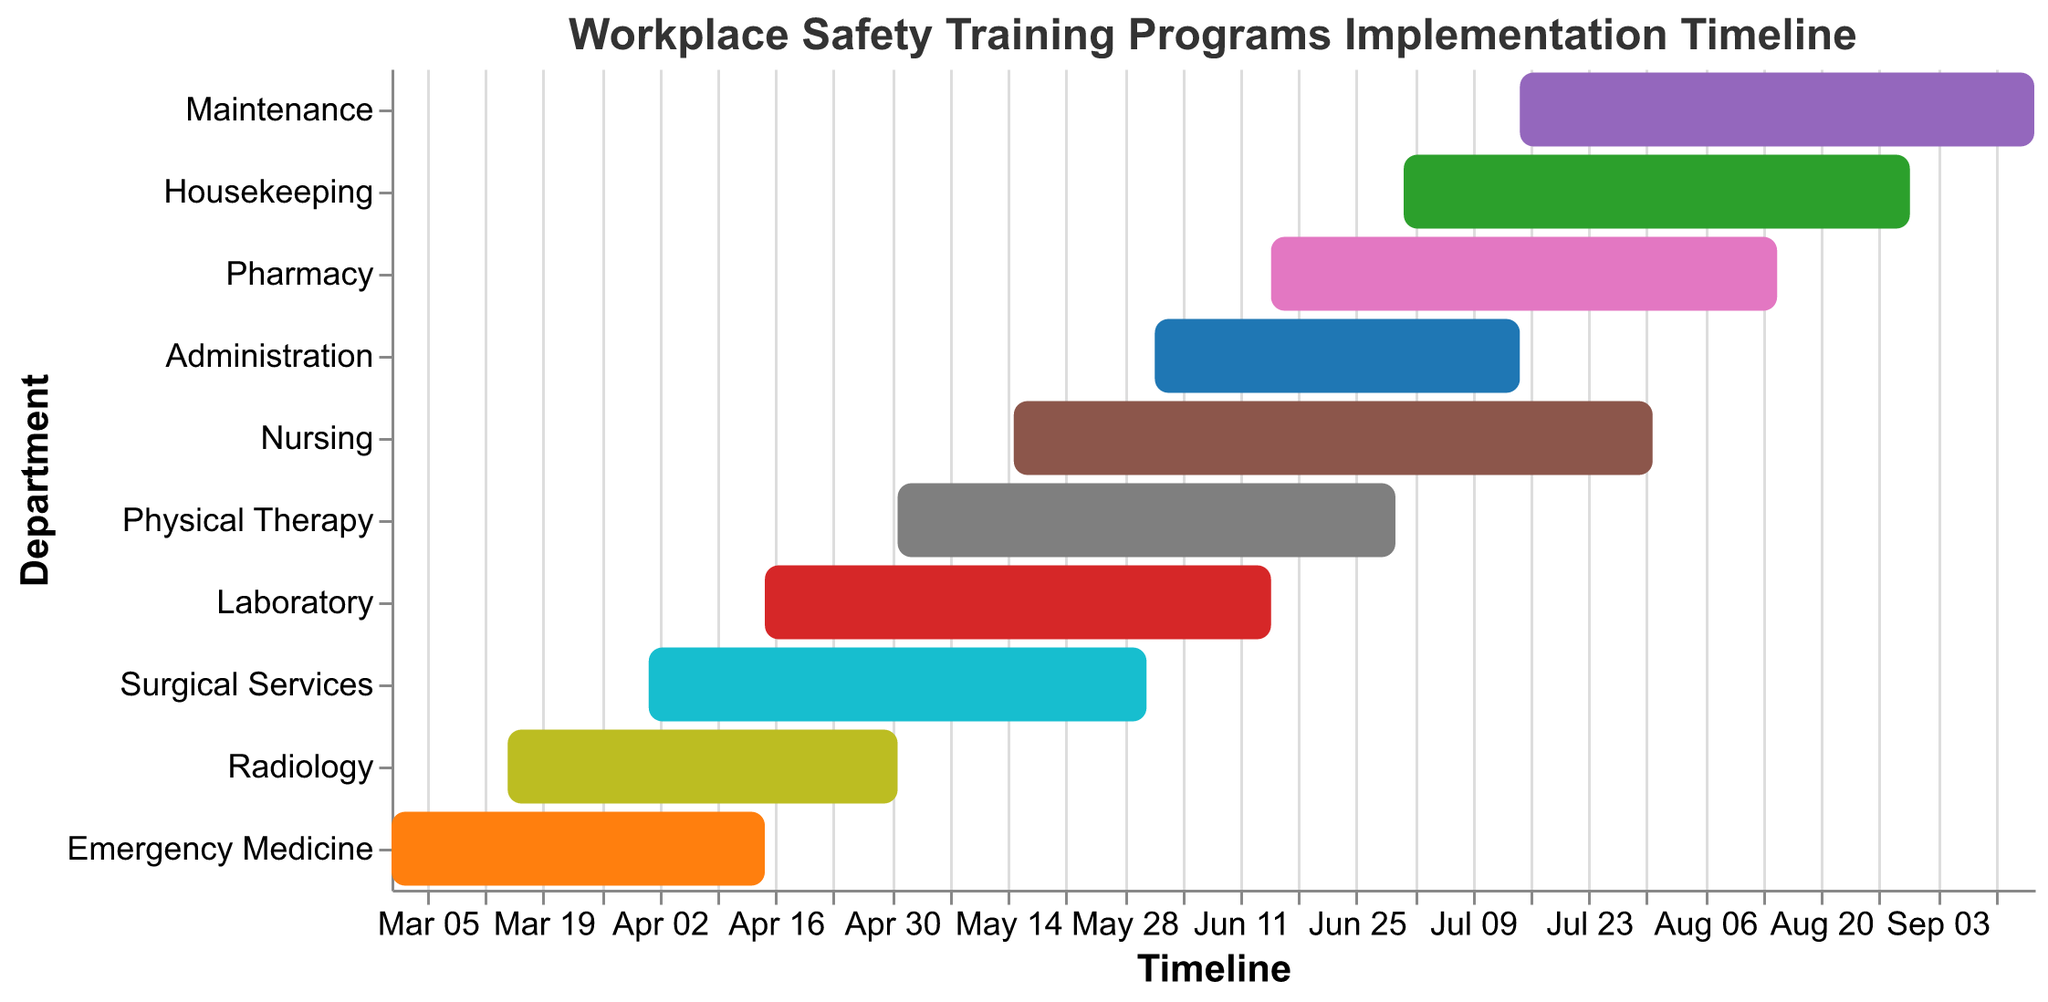How many departments have their training programs starting after June 1st, 2023? To find this, look at the start dates on the x-axis and count the departments whose bars begin after June 1st, 2023.
Answer: 5 Which department has the longest duration for its training program? Check the length of the bars by comparing the start and end dates for each department. The department with the longest bar is the one with the longest duration.
Answer: Maintenance When does the Laboratory department start and end its training program? Refer to the Laboratory department bar and look at the tooltip or x-axis for the start and end dates.
Answer: April 15, 2023 - June 15, 2023 Are there any departments that have overlapping training periods? Identify overlapping bars by checking if any start dates occur before other department’s end dates within the same timeframe.
Answer: Yes, multiple departments overlap Which two departments have the closest start dates? Compare the start dates of all departments to find the pair with the smallest difference in start dates.
Answer: Emergency Medicine and Radiology What is the total number of days for the Nursing training program? Calculate the difference between the start and end dates for Nursing. May 15, 2023 to July 31, 2023 results in (31+30+15) days.
Answer: 77 days How many departments have their training programs extending into August 2023? Identify the departments that have end dates in August 2023 by looking at the end section of the bars.
Answer: 4 Is there a department that starts its training program before another finishes on the same day? Check the start and end dates of departments to see if any one department's start date aligns with another department’s end date.
Answer: No Which department has the shortest duration for its training program? Compare the lengths of all the bars by looking at start and end dates and identify the shortest one.
Answer: Administration What is the average duration of all training programs? Calculate the duration for each department, sum them up, and divide by the number of departments. The sum is calculated by converting all durations to days, summing them, and then dividing by the number of departments.
Answer: 64 days 